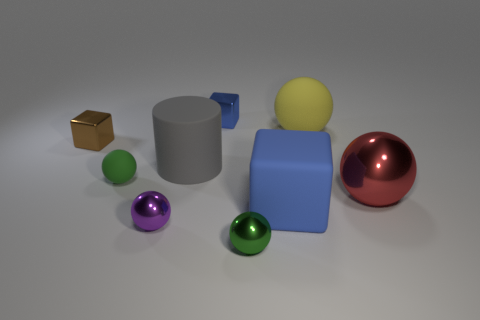Can you tell me what shapes are visible in the scene? Certainly! The image showcases a variety of geometric shapes including a sphere (the large red ball and smaller colored balls), a cube (the gold object), a cylinder (the grey object), and a rectangular prism (the blue block).  What can you say about the colors used in this image? The image features a vivid array of colors. Apart from the red, green, purple, and gold objects, there's a large blue block, a pastel yellow ball, and a grey cylinder, all set against a white background that makes the colors stand out. 